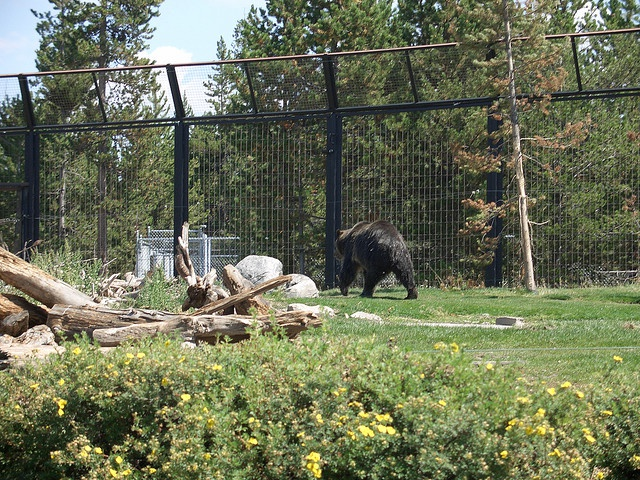Describe the objects in this image and their specific colors. I can see a bear in lavender, black, gray, and darkgray tones in this image. 